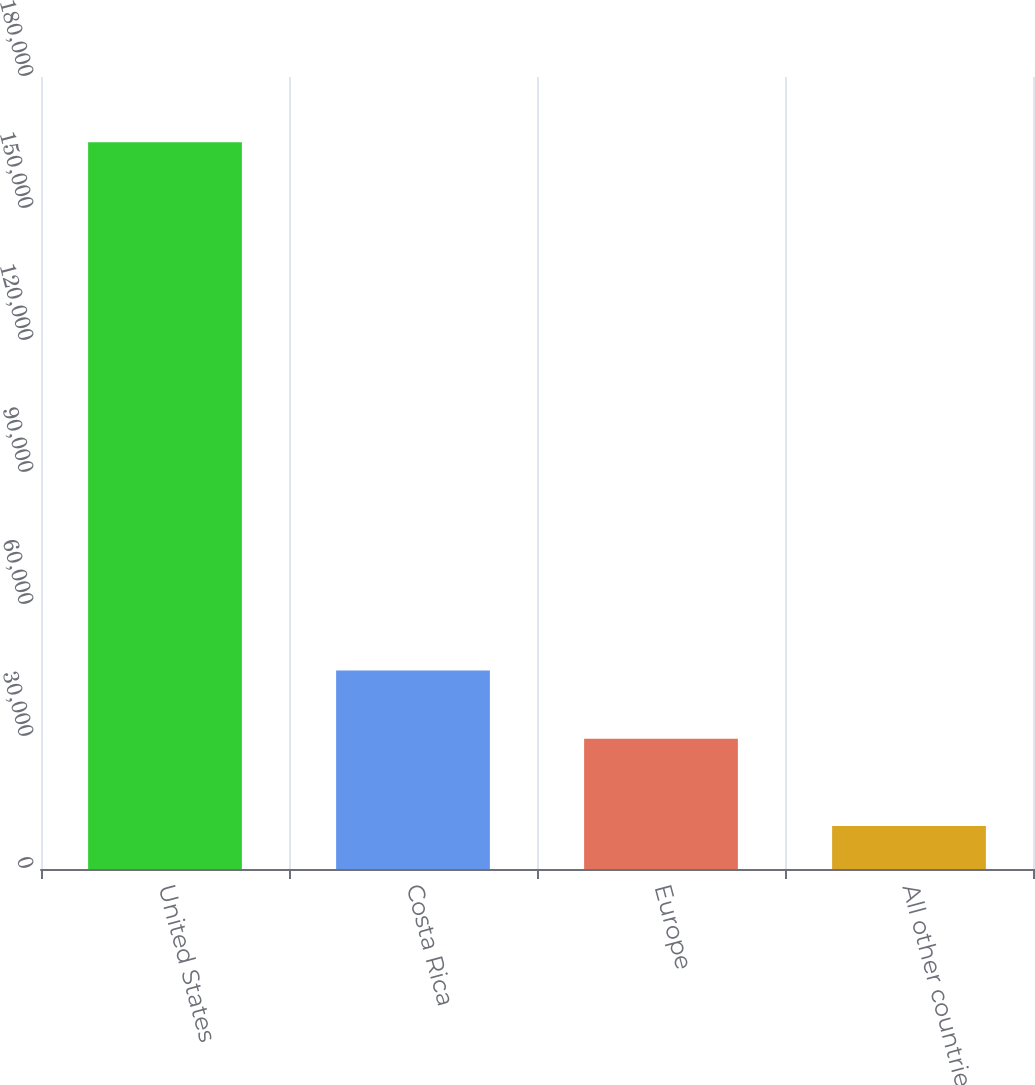<chart> <loc_0><loc_0><loc_500><loc_500><bar_chart><fcel>United States<fcel>Costa Rica<fcel>Europe<fcel>All other countries<nl><fcel>165177<fcel>45129.6<fcel>29591<fcel>9791<nl></chart> 